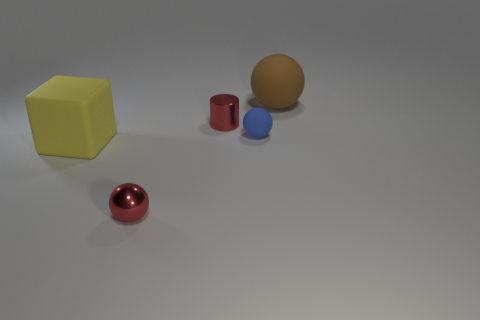How many large brown rubber objects are right of the large brown thing?
Your answer should be compact. 0. What material is the sphere that is right of the red metal cylinder and on the left side of the large rubber ball?
Your response must be concise. Rubber. What number of spheres are either large yellow things or matte objects?
Offer a very short reply. 2. There is a small red object that is the same shape as the tiny blue rubber object; what is its material?
Offer a terse response. Metal. What is the size of the ball that is the same material as the blue thing?
Offer a terse response. Large. There is a tiny red object that is behind the large block; does it have the same shape as the big rubber object that is right of the tiny red metallic ball?
Make the answer very short. No. There is a large block that is the same material as the brown object; what is its color?
Provide a succinct answer. Yellow. Does the red thing that is in front of the tiny metallic cylinder have the same size as the shiny thing that is to the right of the tiny red ball?
Your response must be concise. Yes. The tiny object that is to the left of the blue rubber ball and behind the small red metallic ball has what shape?
Offer a terse response. Cylinder. Are there any yellow things made of the same material as the red sphere?
Offer a very short reply. No. 